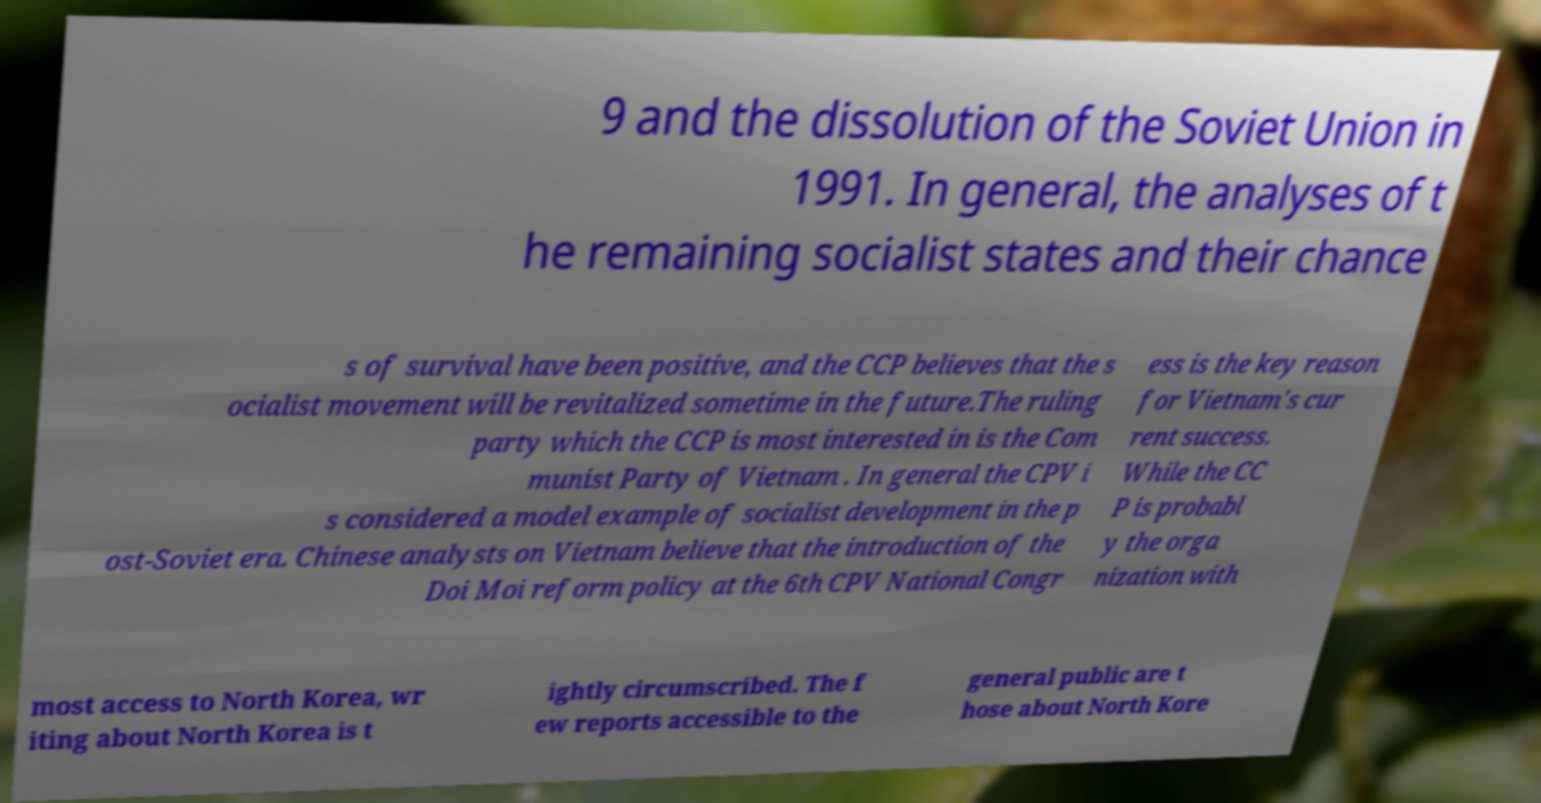There's text embedded in this image that I need extracted. Can you transcribe it verbatim? 9 and the dissolution of the Soviet Union in 1991. In general, the analyses of t he remaining socialist states and their chance s of survival have been positive, and the CCP believes that the s ocialist movement will be revitalized sometime in the future.The ruling party which the CCP is most interested in is the Com munist Party of Vietnam . In general the CPV i s considered a model example of socialist development in the p ost-Soviet era. Chinese analysts on Vietnam believe that the introduction of the Doi Moi reform policy at the 6th CPV National Congr ess is the key reason for Vietnam's cur rent success. While the CC P is probabl y the orga nization with most access to North Korea, wr iting about North Korea is t ightly circumscribed. The f ew reports accessible to the general public are t hose about North Kore 